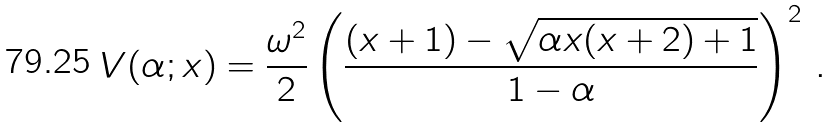Convert formula to latex. <formula><loc_0><loc_0><loc_500><loc_500>V ( \alpha ; x ) = \frac { \omega ^ { 2 } } { 2 } \left ( \frac { ( x + 1 ) - \sqrt { \alpha x ( x + 2 ) + 1 } } { 1 - \alpha } \right ) ^ { 2 } \, .</formula> 